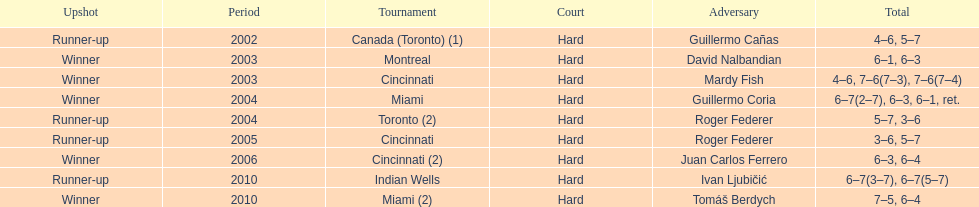How many times has he secured the runner-up position? 4. 